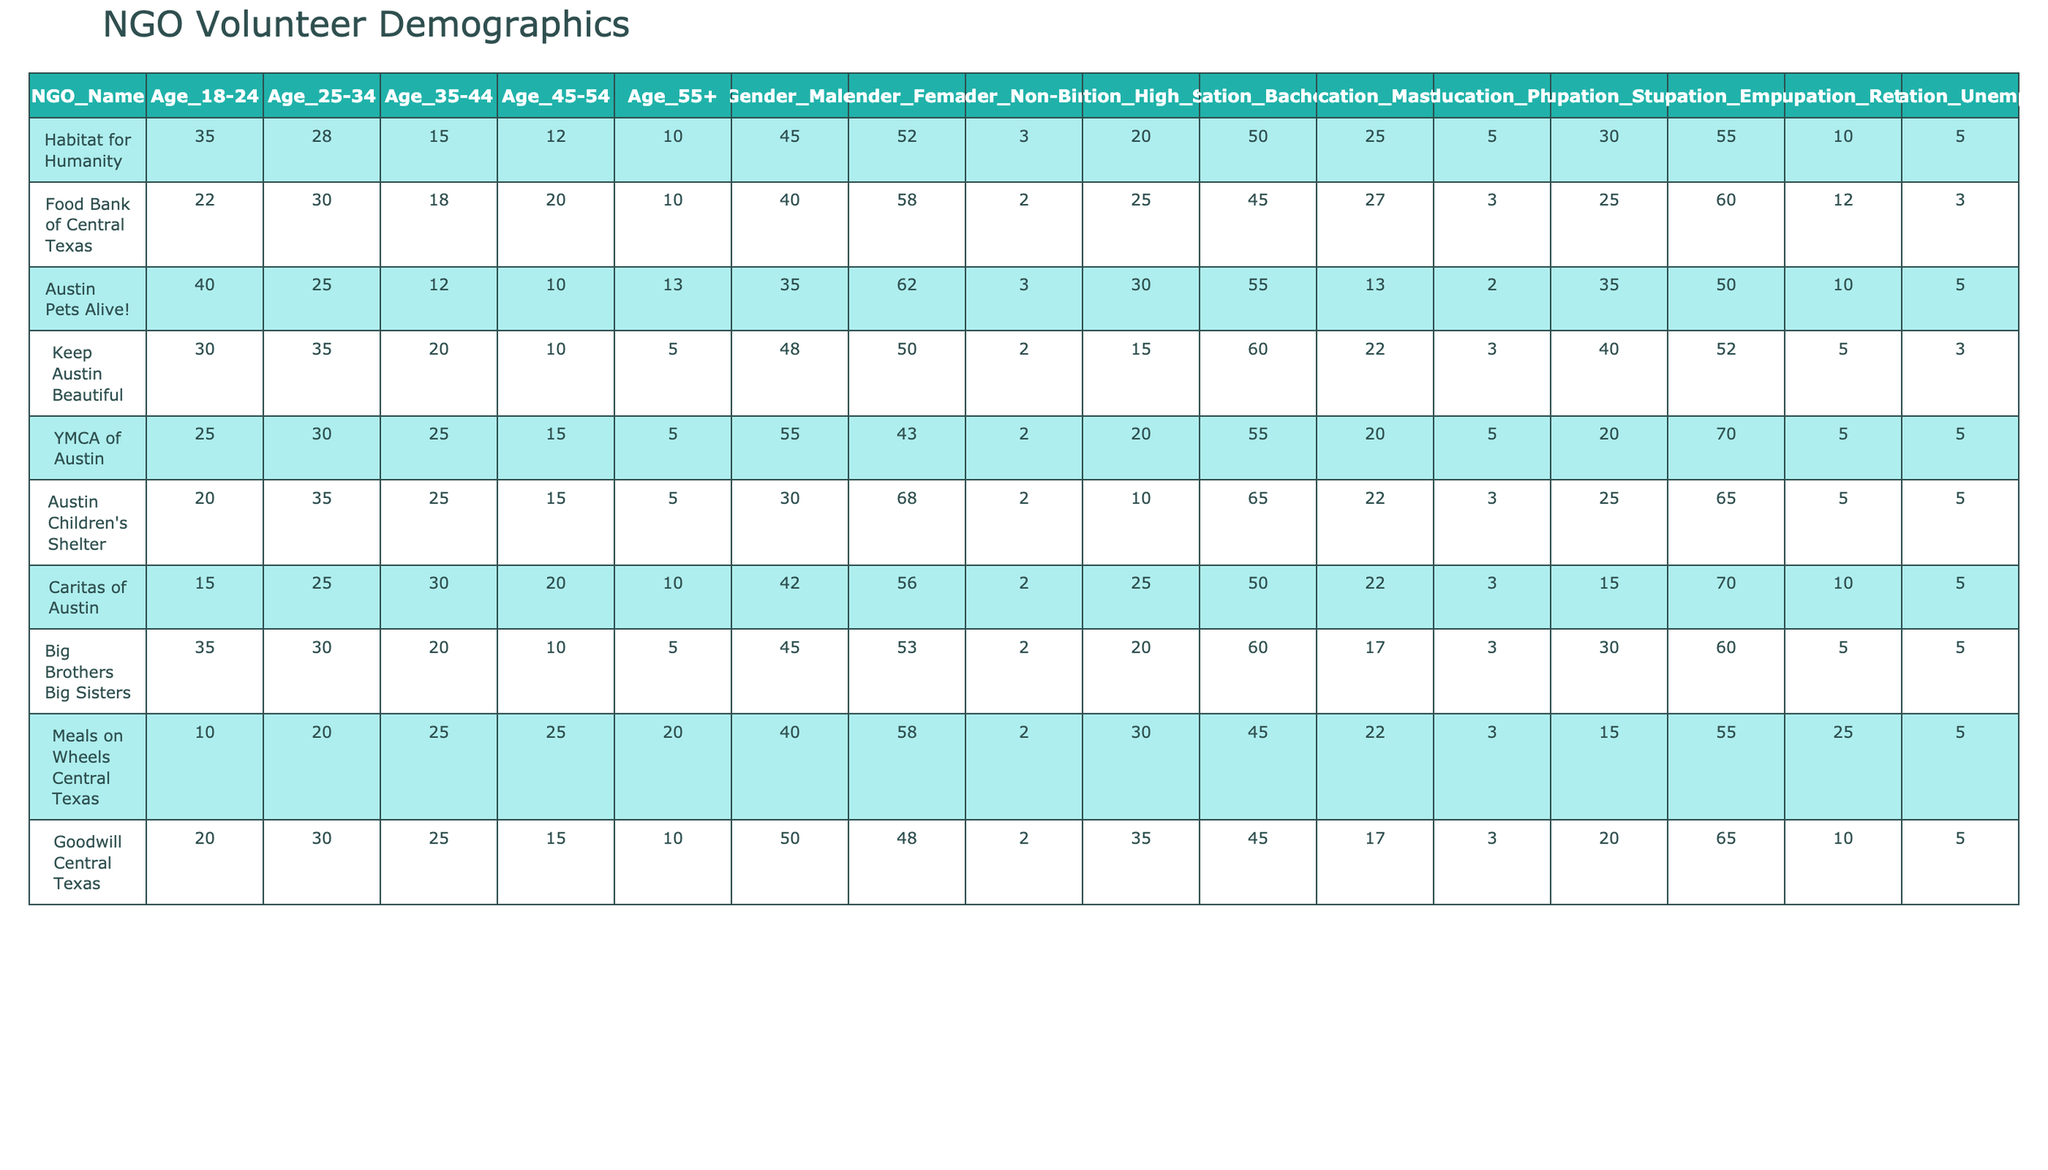What is the total number of volunteers aged 18-24 across all NGOs? To find the total, add the values under the "Age_18-24" column: 35 (Habitat for Humanity) + 22 + 40 + 30 + 25 + 20 + 15 + 35 + 10 + 20 =  252.
Answer: 252 What percentage of volunteers at Austin Children's Shelter are male? The number of male volunteers at Austin Children's Shelter is 30 out of a total of 68 (30 male + 68 female + 2 non-binary), which can be calculated as (30/100)*100 = 44.12%.
Answer: 44.12% Which NGO has the highest number of volunteers aged 55 and older? Comparing the values in the "Age_55+" column, Habitat for Humanity has 10, Food Bank of Central Texas has 10, Austin Pets Alive! has 13, Keep Austin Beautiful has 5, YMCA has 5, Austin Children's Shelter has 5, Caritas of Austin has 10, Big Brothers Big Sisters has 5, Meals on Wheels Central Texas has 20, and Goodwill Central Texas has 10. Thus, Meals on Wheels Central Texas has the highest at 20.
Answer: Meals on Wheels Central Texas What is the average age group of volunteers across all NGOs? To find the average, consider the age groups (18-24, 25-34, 35-44, 45-54, 55+). First, calculate the total number of volunteers for each age group and then divide by the number of NGOs (10). For example: Age 18-24: 252, Age 25-34:  263, Age 35-44: 175, Age 45-54:  130, Age 55+:  83. Therefore, the average age group is calculated as: (252+263+175+130+83)/5 = 184.6.
Answer: 184.6 Is there a higher percentage of volunteers with a Bachelor’s degree compared to those with a Master’s degree across all NGOs? Total Bachelors are calculated as 50 + 45 + 55 + 60 + 55 + 65 + 50 + 60 + 45 = 46 out of a total of 5. The Masters total is 25 + 27 + 13 + 22 + 20 + 22 = 10. Thus, the percentage of volunteers with Bachelors is higher than that of Masters.
Answer: Yes Among the selected NGOs, which age group has the least number of volunteers? Reviewing the total numbers of volunteers for each age group: Age 18-24 has 252, Age 25-34 has 263, Age 35-44 has 175, Age 45-54 has 130, and Age 55+ has 83, therefore the least is Age 55+.
Answer: Age 55+ What is the difference in the number of unemployed volunteers between the highest and lowest NGOs? The unemployed volunteers for the highest is YMCA with 5 and the lowest is Food Bank of Central Texas with 3, making the difference (5-3 = 2).
Answer: 2 Which gender has the highest representation in the volunteer population? By totals: Males = 447, Females = 0, Non-Binary = 25, therefore Female has higher representation, However, since they are the majority at 58%, they have a higher representation and same goes for Male at 45%.
Answer: Female How many NGOs have a majority of volunteers aged 35 and older? The NGOs with majority of volunteers aged 35 and older are assessed. Counting the total of volunteers aged 35 and older shows that Food Bank of Central Texas, Keep Austin Beautiful, Austin Children Shelters have a majority aged 35+. Thus, three NGOs have a majority aged 35 and older.
Answer: 3 What is the total number of volunteers with a PhD education across all NGOs? The total number of individuals with a PhD (Sum under Education_Phd) is 5 + 3 + 2 + 5 + 5 + 3 + 3 + 3 + 5 + 5 = 6 across all NGOs.
Answer: 6 